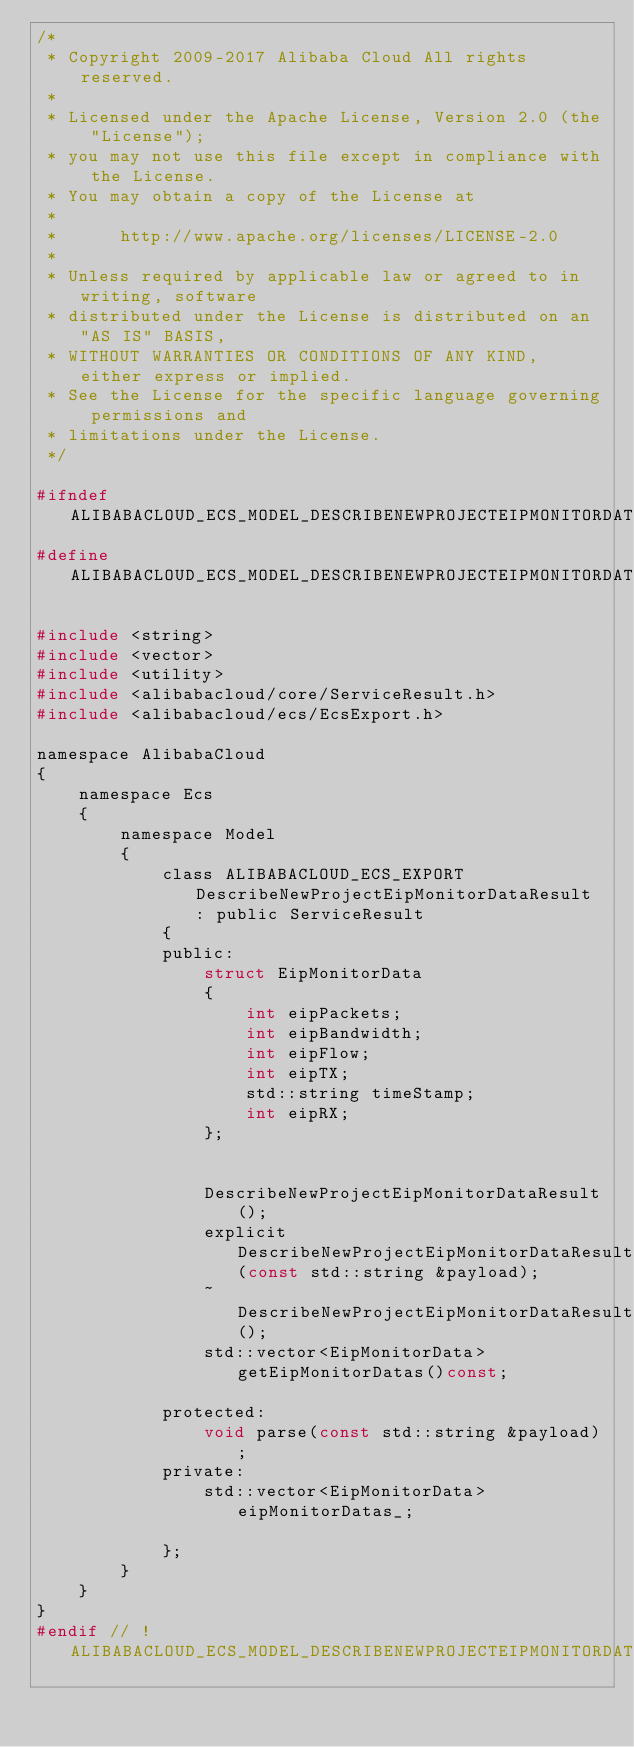<code> <loc_0><loc_0><loc_500><loc_500><_C_>/*
 * Copyright 2009-2017 Alibaba Cloud All rights reserved.
 * 
 * Licensed under the Apache License, Version 2.0 (the "License");
 * you may not use this file except in compliance with the License.
 * You may obtain a copy of the License at
 * 
 *      http://www.apache.org/licenses/LICENSE-2.0
 * 
 * Unless required by applicable law or agreed to in writing, software
 * distributed under the License is distributed on an "AS IS" BASIS,
 * WITHOUT WARRANTIES OR CONDITIONS OF ANY KIND, either express or implied.
 * See the License for the specific language governing permissions and
 * limitations under the License.
 */

#ifndef ALIBABACLOUD_ECS_MODEL_DESCRIBENEWPROJECTEIPMONITORDATARESULT_H_
#define ALIBABACLOUD_ECS_MODEL_DESCRIBENEWPROJECTEIPMONITORDATARESULT_H_

#include <string>
#include <vector>
#include <utility>
#include <alibabacloud/core/ServiceResult.h>
#include <alibabacloud/ecs/EcsExport.h>

namespace AlibabaCloud
{
	namespace Ecs
	{
		namespace Model
		{
			class ALIBABACLOUD_ECS_EXPORT DescribeNewProjectEipMonitorDataResult : public ServiceResult
			{
			public:
				struct EipMonitorData
				{
					int eipPackets;
					int eipBandwidth;
					int eipFlow;
					int eipTX;
					std::string timeStamp;
					int eipRX;
				};


				DescribeNewProjectEipMonitorDataResult();
				explicit DescribeNewProjectEipMonitorDataResult(const std::string &payload);
				~DescribeNewProjectEipMonitorDataResult();
				std::vector<EipMonitorData> getEipMonitorDatas()const;

			protected:
				void parse(const std::string &payload);
			private:
				std::vector<EipMonitorData> eipMonitorDatas_;

			};
		}
	}
}
#endif // !ALIBABACLOUD_ECS_MODEL_DESCRIBENEWPROJECTEIPMONITORDATARESULT_H_</code> 